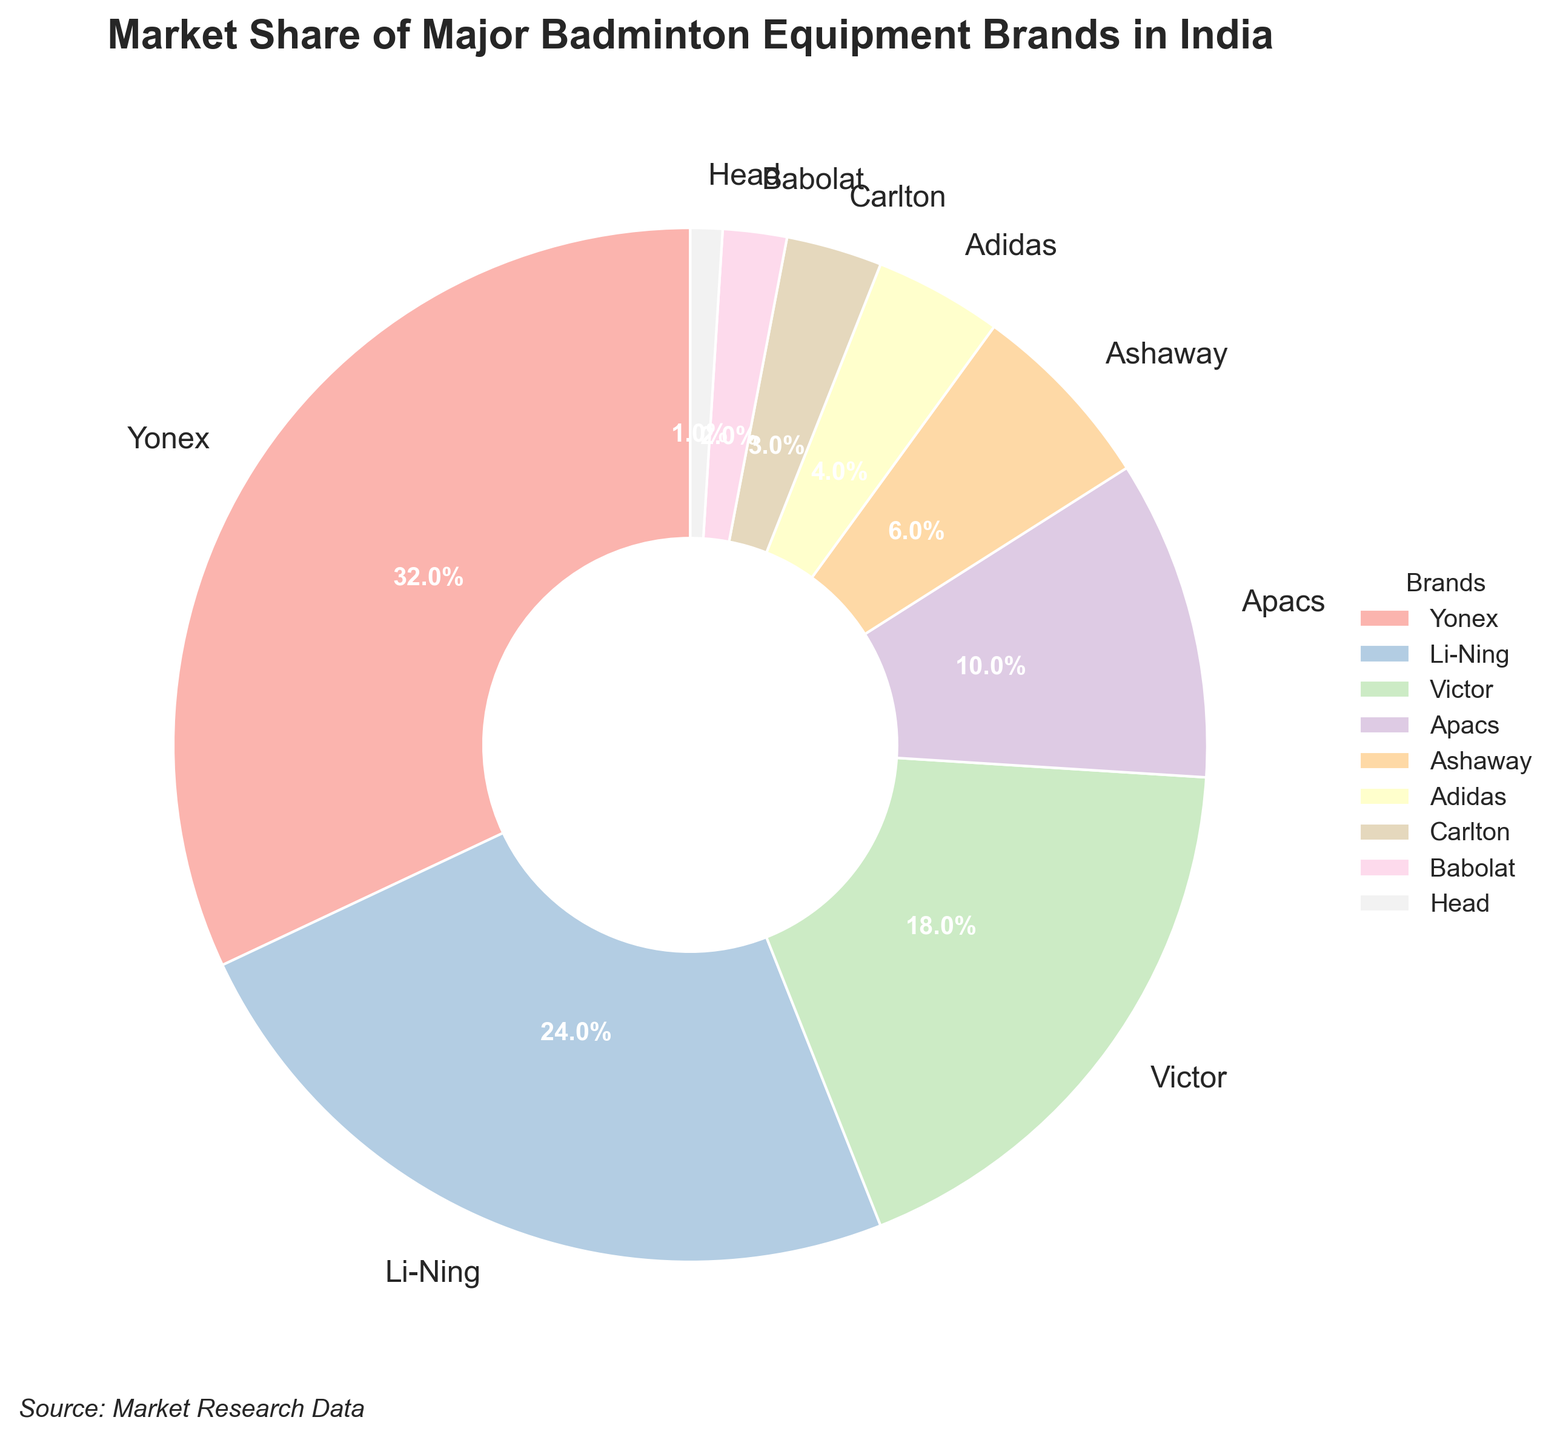Which brand has the largest market share? The figure shows market shares of different brands, and Yonex has the largest slice in the pie chart with 32%.
Answer: Yonex Which brand has the smallest market share? The figure shows market shares of different brands, and Head has the smallest slice in the pie chart with just 1%.
Answer: Head How much larger is Yonex's market share compared to adidas? Yonex has a market share of 32% and adidas has 4%. Subtracting 4 from 32 gives 28%.
Answer: 28% What is the combined market share of the top three brands? Yonex has 32%, Li-Ning has 24%, and Victor has 18%. Summing these gives 32 + 24 + 18 = 74%.
Answer: 74% What is the difference in market share between Victor and Apacs? Victor has 18% and Apacs has 10%. Subtracting 10 from 18 gives 8%.
Answer: 8% How many brands have a market share of less than 10%? The brands with less than 10% are Apacs (10%), Ashaway (6%), adidas (4%), Carlton (3%), Babolat (2%), and Head (1%). That makes a total of 6 brands.
Answer: 6 Which brand shares are closest in size? Li-Ning has 24% and Victor has 18%, making them the closest in market shares with a difference of 6%.
Answer: Li-Ning and Victor Is the combined market share of Carlton and Babolat greater than Ashaway's market share by 1%? Carlton has 3% and Babolat has 2%. Their combined market share is 3 + 2 = 5%, which is 1% less than Ashaway’s share of 6%.
Answer: No What is the average market share of all listed brands? Sum all percentages: 32 + 24 + 18 + 10 + 6 + 4 + 3 + 2 + 1 = 100. There are 9 brands. The average is 100/9 ≈ 11.11%.
Answer: 11.11% What percentage of the market is controlled by brands other than the top three? The top three brands have 32%, 24%, and 18%, summing to 74%. Therefore, the others combined have 100 - 74 = 26%.
Answer: 26% 